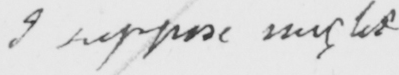What is written in this line of handwriting? I suppose might 